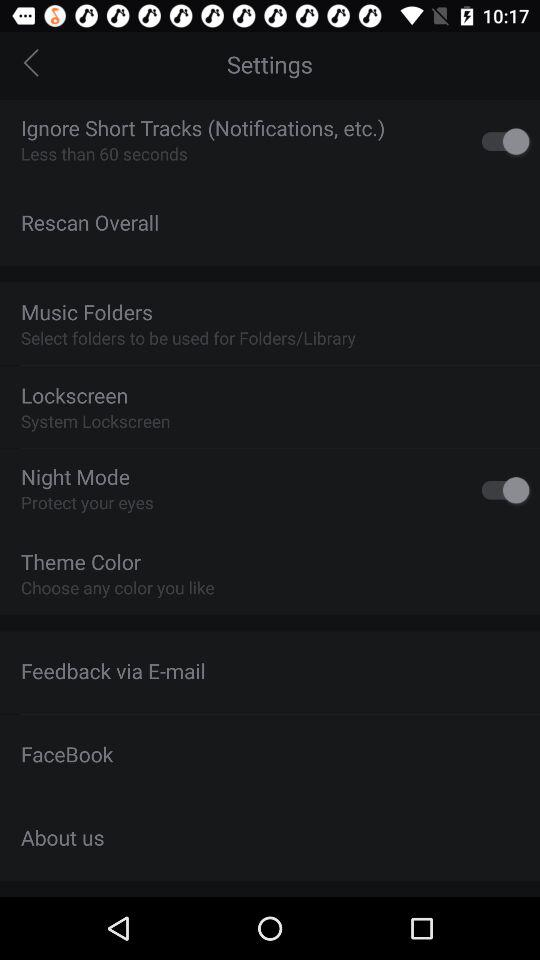what is the status of "About us"?
When the provided information is insufficient, respond with <no answer>. <no answer> 